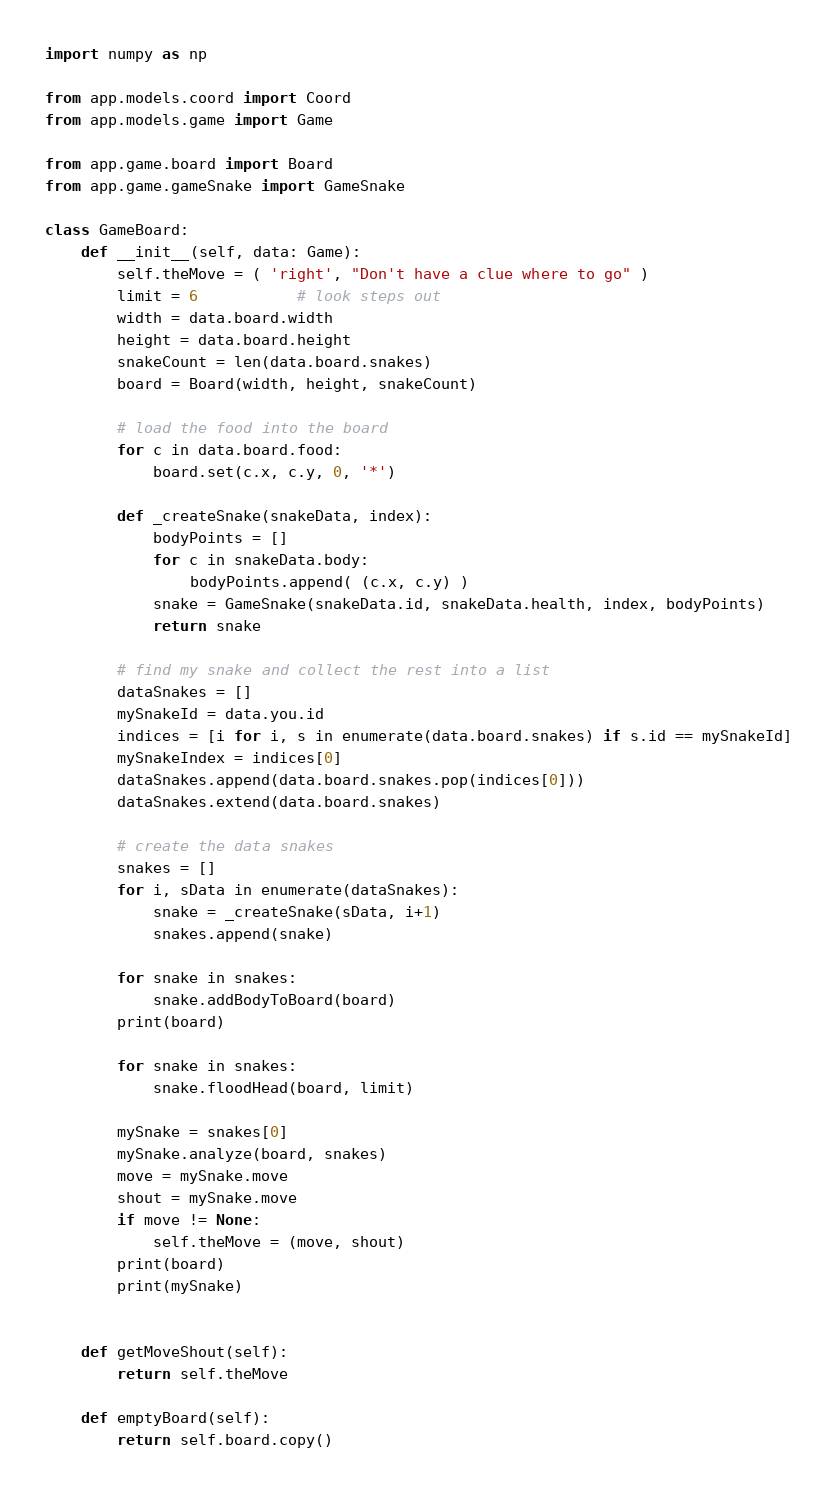Convert code to text. <code><loc_0><loc_0><loc_500><loc_500><_Python_>import numpy as np

from app.models.coord import Coord
from app.models.game import Game

from app.game.board import Board
from app.game.gameSnake import GameSnake

class GameBoard:
    def __init__(self, data: Game):
        self.theMove = ( 'right', "Don't have a clue where to go" )
        limit = 6           # look steps out
        width = data.board.width
        height = data.board.height
        snakeCount = len(data.board.snakes)
        board = Board(width, height, snakeCount)

        # load the food into the board
        for c in data.board.food:
            board.set(c.x, c.y, 0, '*')

        def _createSnake(snakeData, index):
            bodyPoints = []
            for c in snakeData.body:
                bodyPoints.append( (c.x, c.y) )
            snake = GameSnake(snakeData.id, snakeData.health, index, bodyPoints)
            return snake

        # find my snake and collect the rest into a list
        dataSnakes = []
        mySnakeId = data.you.id
        indices = [i for i, s in enumerate(data.board.snakes) if s.id == mySnakeId]
        mySnakeIndex = indices[0]
        dataSnakes.append(data.board.snakes.pop(indices[0]))
        dataSnakes.extend(data.board.snakes)

        # create the data snakes
        snakes = []
        for i, sData in enumerate(dataSnakes):
            snake = _createSnake(sData, i+1)
            snakes.append(snake)

        for snake in snakes:
            snake.addBodyToBoard(board)
        print(board)

        for snake in snakes:
            snake.floodHead(board, limit)
            
        mySnake = snakes[0]
        mySnake.analyze(board, snakes)
        move = mySnake.move
        shout = mySnake.move
        if move != None:
            self.theMove = (move, shout)
        print(board)
        print(mySnake)


    def getMoveShout(self):
        return self.theMove

    def emptyBoard(self):
        return self.board.copy()
</code> 